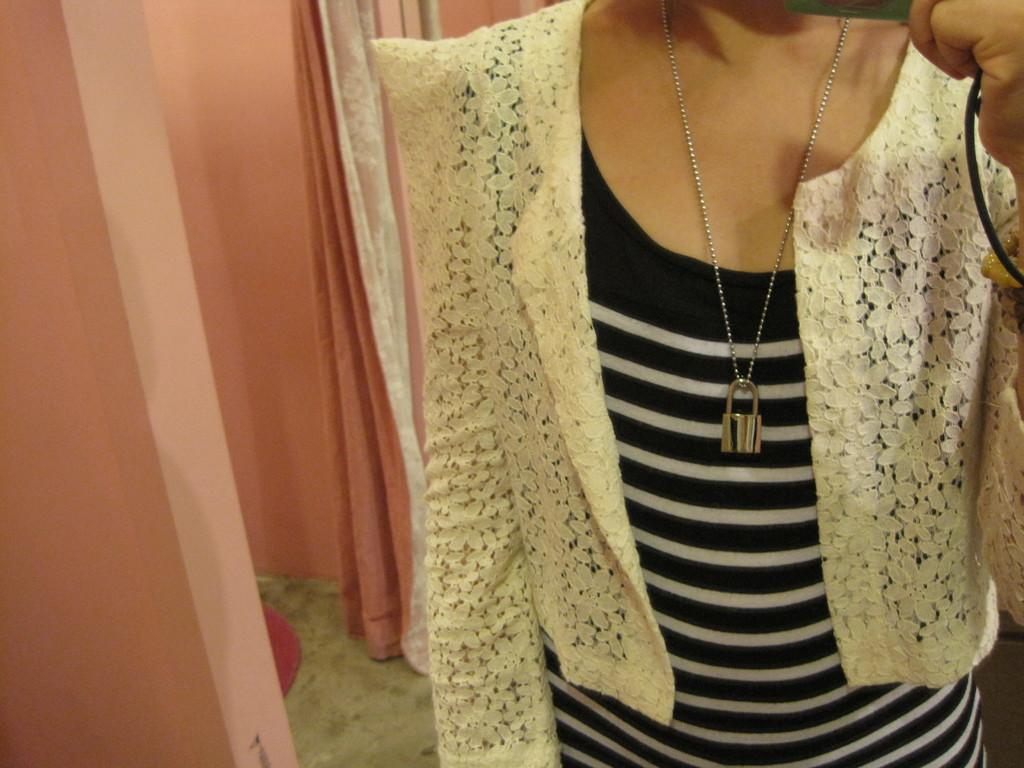What is the person in the image holding? There is a person holding an object in the image. What can be seen in the background of the image? There is a wall in the image. What is the surface beneath the person's feet? There is a floor in the image. Is there any additional floor covering visible? Yes, there is a floor mat in the image. Where is the curtain located in the image? There is a curtain in the image, specifically on the left side. What type of jam is being spread on the secretary's desk in the image? There is no secretary or jam present in the image. 